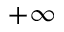<formula> <loc_0><loc_0><loc_500><loc_500>+ \infty</formula> 